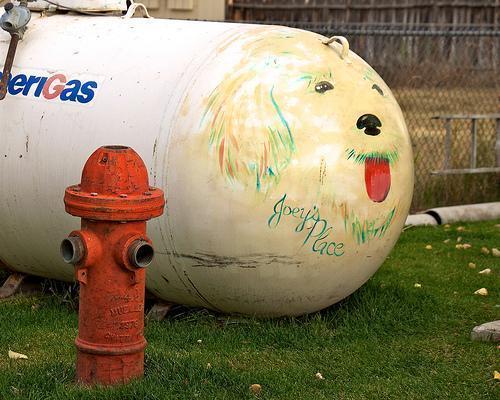How many fire hydrants are there?
Give a very brief answer. 1. 